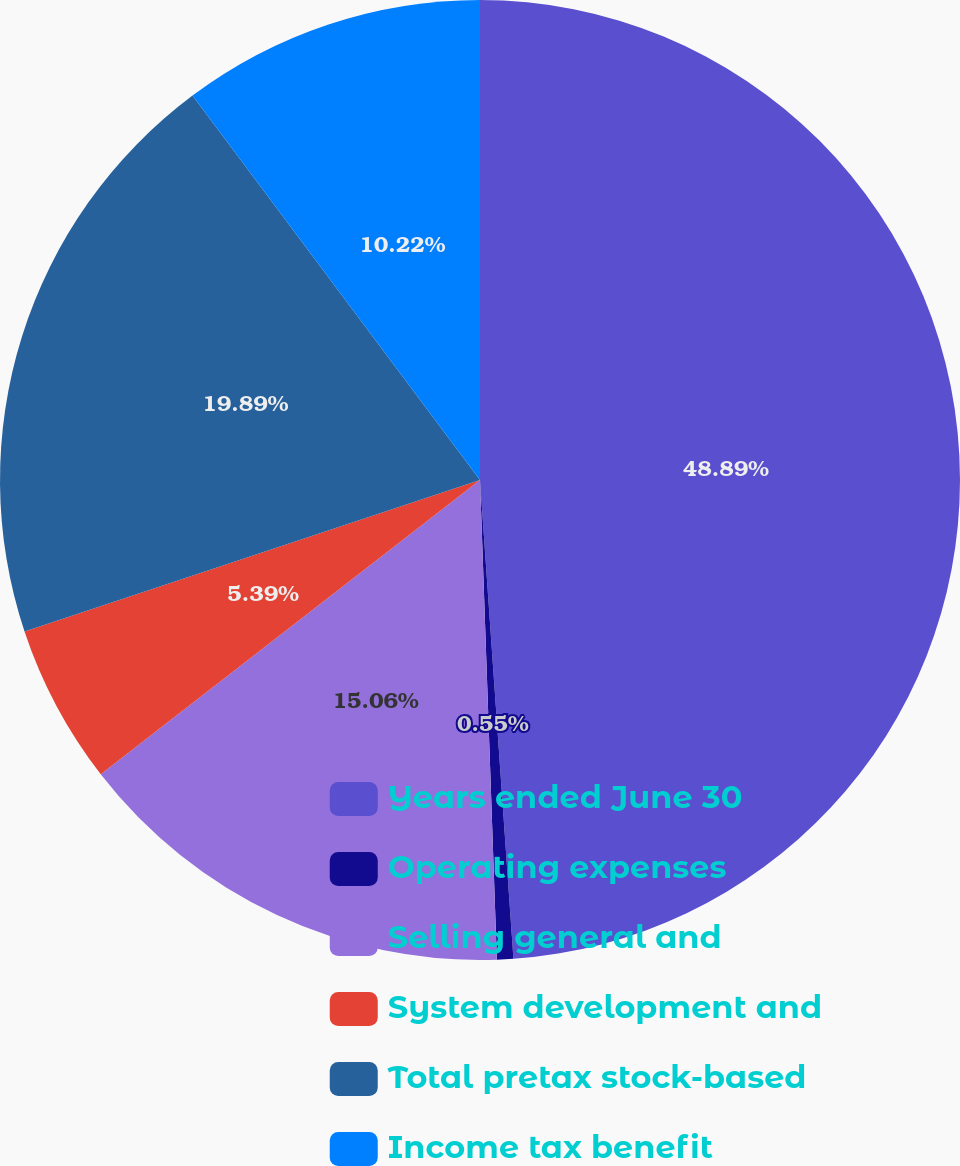Convert chart to OTSL. <chart><loc_0><loc_0><loc_500><loc_500><pie_chart><fcel>Years ended June 30<fcel>Operating expenses<fcel>Selling general and<fcel>System development and<fcel>Total pretax stock-based<fcel>Income tax benefit<nl><fcel>48.89%<fcel>0.55%<fcel>15.06%<fcel>5.39%<fcel>19.89%<fcel>10.22%<nl></chart> 